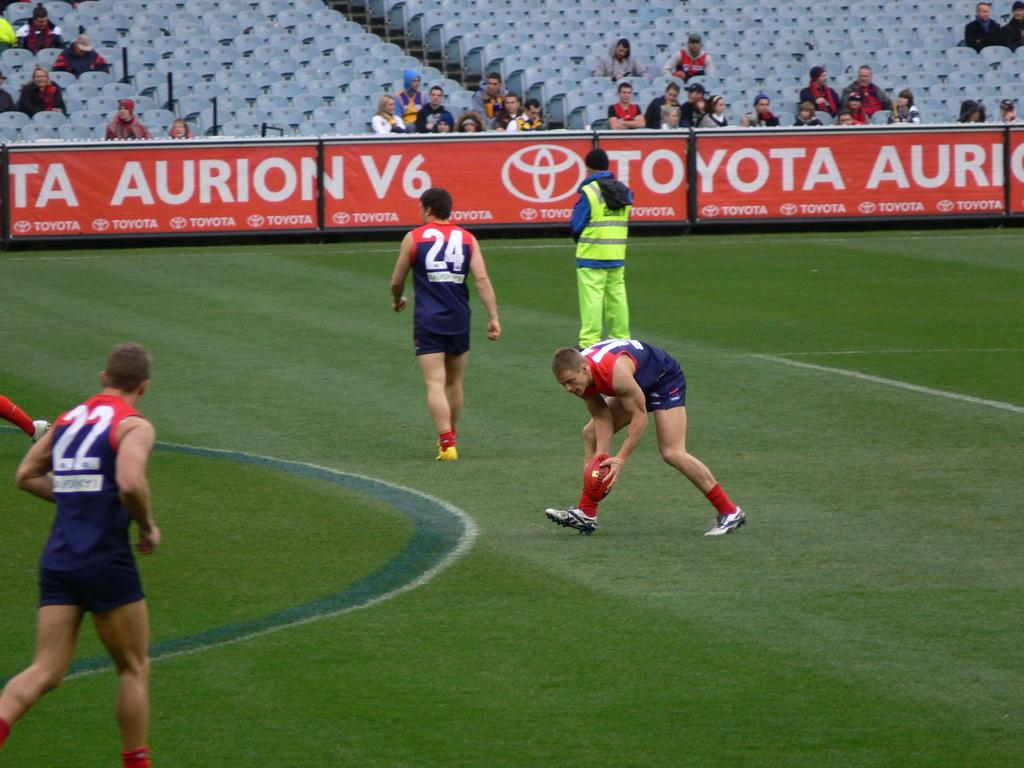<image>
Present a compact description of the photo's key features. A rugby player wearing number 24 walks away from another player setting the ball on the ground. 